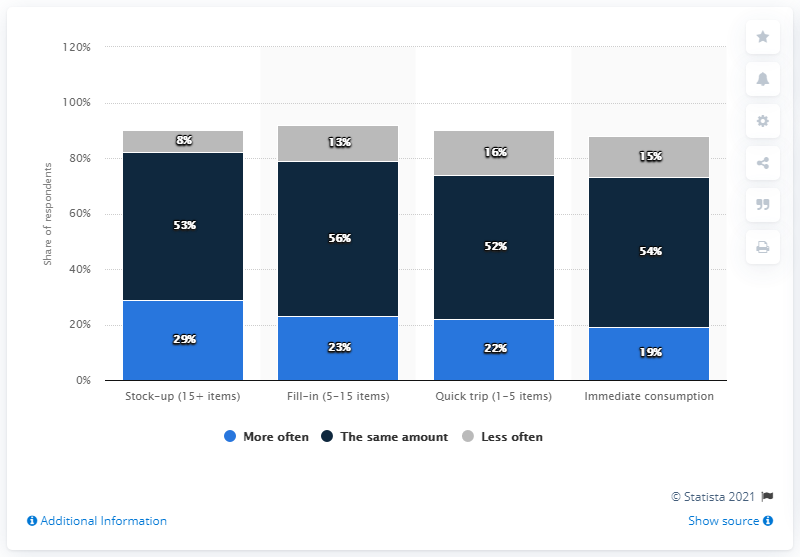Point out several critical features in this image. According to the data, 19% of respondents reported that they had increased the frequency of their shopping trips for immediate consumption. 